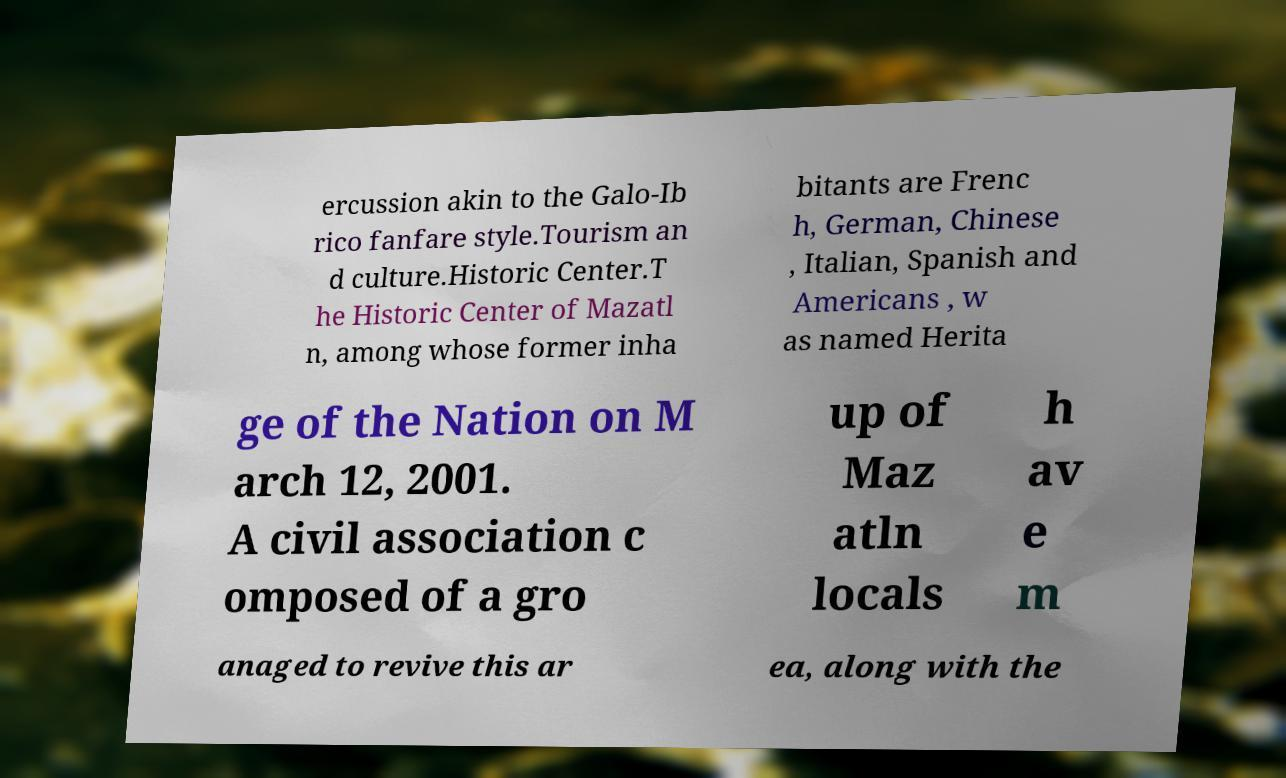Can you accurately transcribe the text from the provided image for me? ercussion akin to the Galo-Ib rico fanfare style.Tourism an d culture.Historic Center.T he Historic Center of Mazatl n, among whose former inha bitants are Frenc h, German, Chinese , Italian, Spanish and Americans , w as named Herita ge of the Nation on M arch 12, 2001. A civil association c omposed of a gro up of Maz atln locals h av e m anaged to revive this ar ea, along with the 